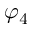<formula> <loc_0><loc_0><loc_500><loc_500>\varphi _ { 4 }</formula> 